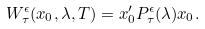<formula> <loc_0><loc_0><loc_500><loc_500>W ^ { \epsilon } _ { \tau } ( x _ { 0 } , \lambda , T ) = x _ { 0 } ^ { \prime } P ^ { \epsilon } _ { \tau } ( \lambda ) x _ { 0 } .</formula> 